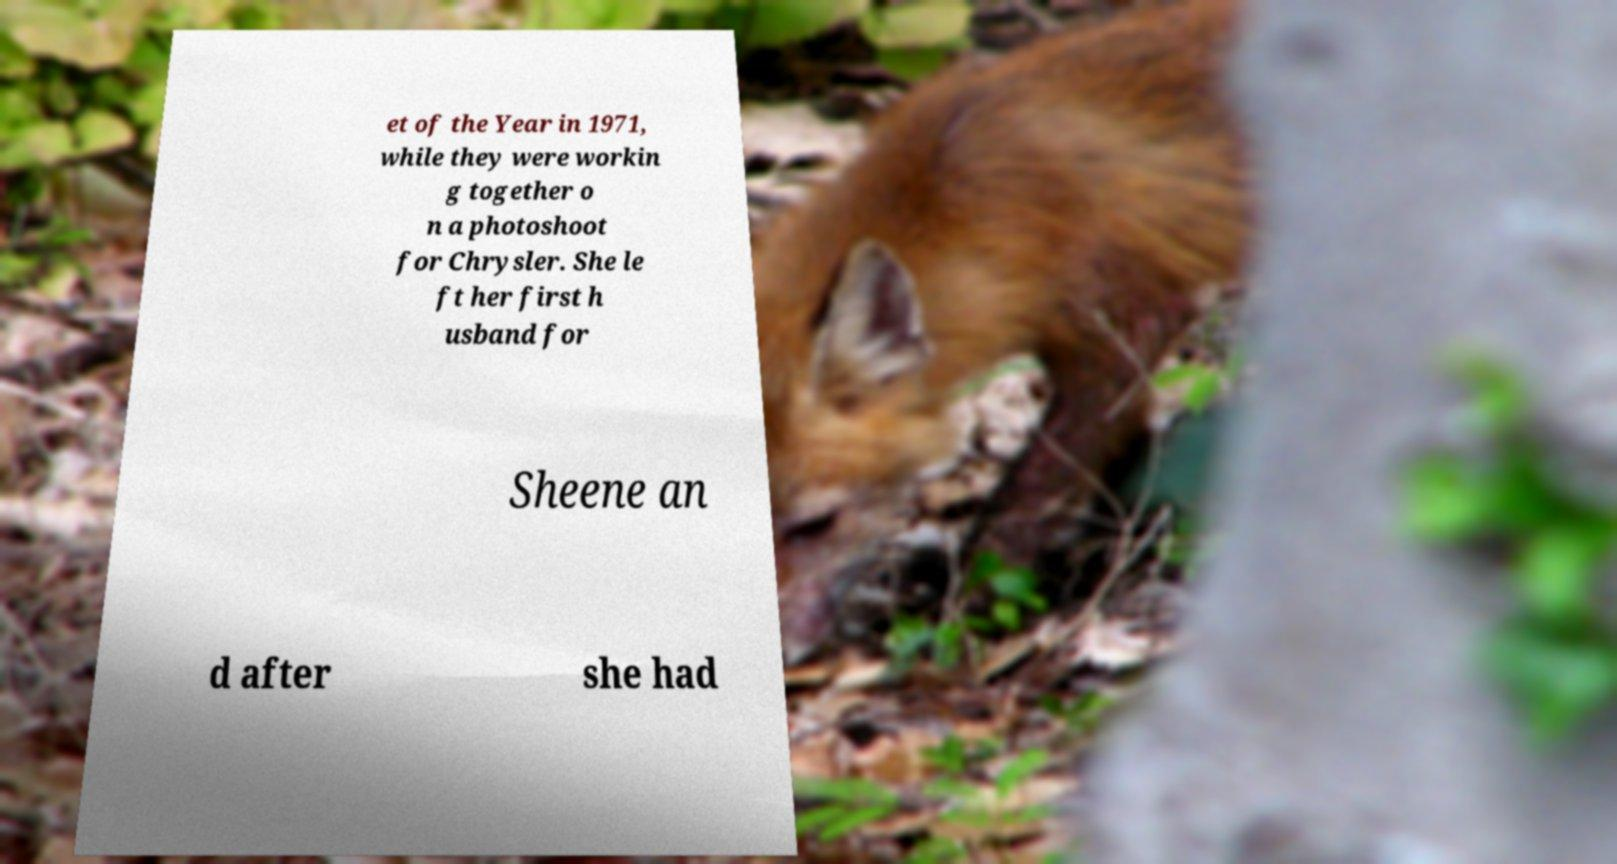For documentation purposes, I need the text within this image transcribed. Could you provide that? et of the Year in 1971, while they were workin g together o n a photoshoot for Chrysler. She le ft her first h usband for Sheene an d after she had 